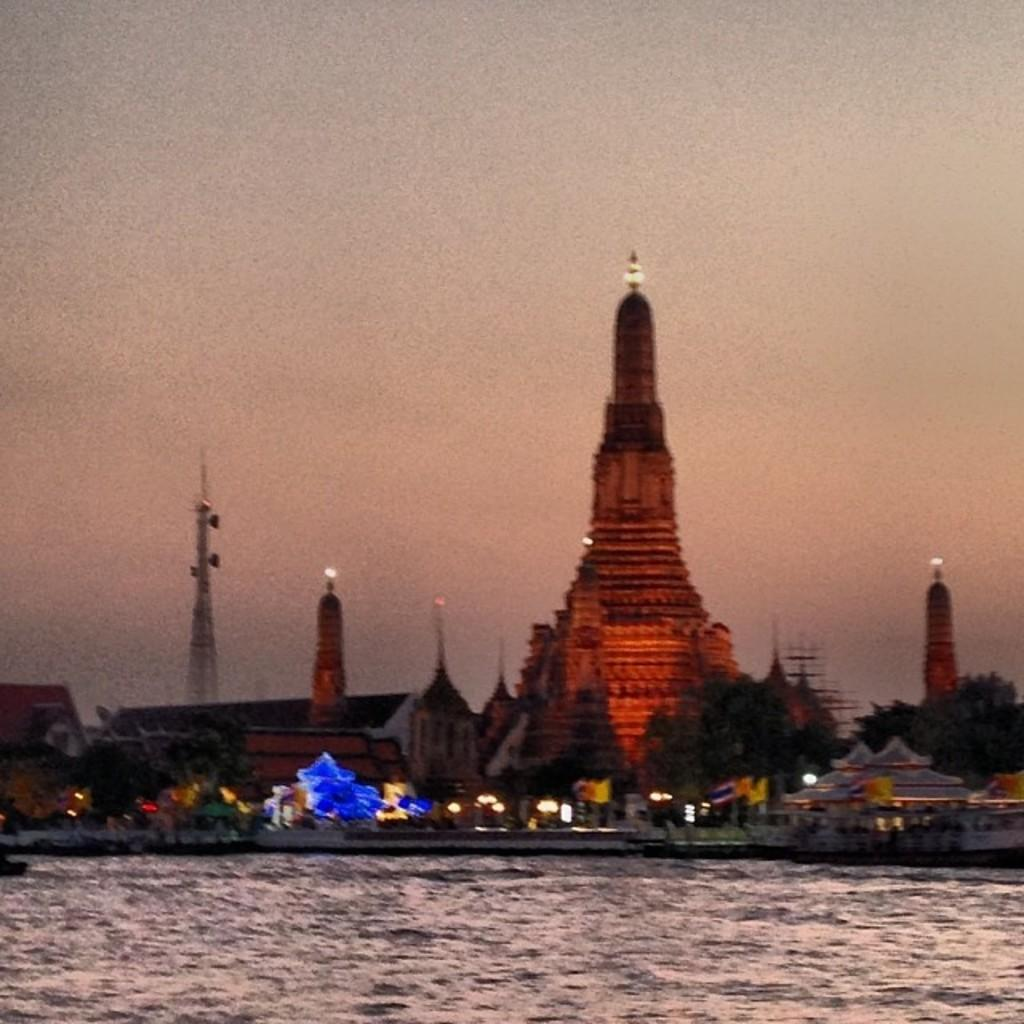What type of structure is the main subject of the image? There is a temple in the image. Can you describe any specific features of the temple? A light is attached at the top of the temple. What else can be seen in the image besides the temple? There is water, buildings, and trees visible in the image. What is visible at the top of the image? The sky is visible at the top of the image. What type of surprise can be seen being cast by the temple in the image? There is no surprise or casting happening in the image; it simply shows a temple with a light attached at the top. 